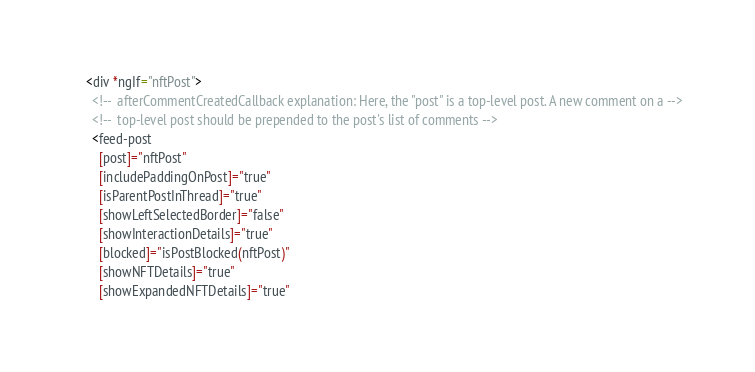Convert code to text. <code><loc_0><loc_0><loc_500><loc_500><_HTML_>    <div *ngIf="nftPost">
      <!--  afterCommentCreatedCallback explanation: Here, the "post" is a top-level post. A new comment on a -->
      <!--  top-level post should be prepended to the post's list of comments -->
      <feed-post
        [post]="nftPost"
        [includePaddingOnPost]="true"
        [isParentPostInThread]="true"
        [showLeftSelectedBorder]="false"
        [showInteractionDetails]="true"
        [blocked]="isPostBlocked(nftPost)"
        [showNFTDetails]="true"
        [showExpandedNFTDetails]="true"</code> 